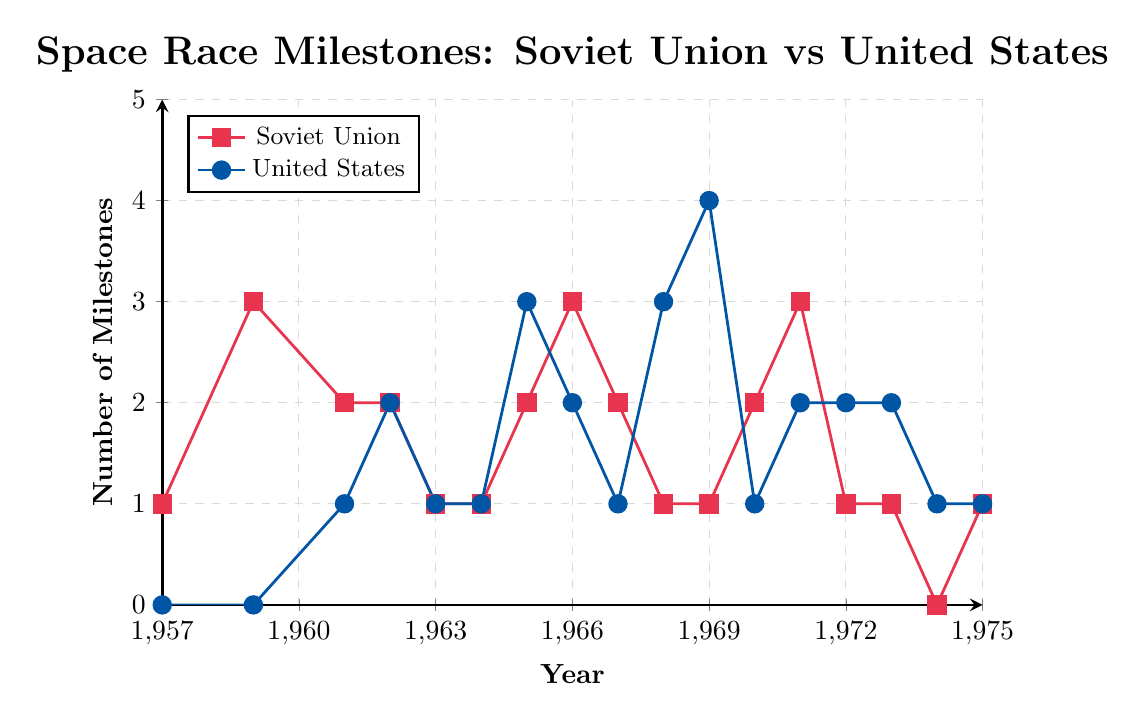What year did the Soviet Union achieve the highest number of space race milestones? To determine the year when the Soviet Union achieved the highest number of space race milestones, observe the red line in the figure and find the peak. The peak appears to be in 1959, 1966, and 1971, where the milestones reached 3.
Answer: 1959, 1966, and 1971 In which year did the United States achieve its highest number of space race milestones, and what was that number? Look at the blue line in the figure and identify its highest point. The highest number is 4, which occurs in 1969.
Answer: 1969, 4 How many more milestones did the Soviet Union achieve in 1959 compared to the United States in the same year? Observe the difference in the height of the lines at the year 1959: The Soviet Union achieved 3 milestones, and the United States achieved 0. The difference is 3 - 0 = 3.
Answer: 3 What is the sum of space race milestones for the Soviet Union from 1970 to 1975? Add the milestones for the years from 1970 to 1975 for the Soviet Union: 2 (1970) + 3 (1971) + 1 (1972) + 1 (1973) + 0 (1974) + 1 (1975). The sum is 2 + 3 + 1 + 1 + 0 + 1 = 8.
Answer: 8 In which year did both the Soviet Union and the United States have an equal number of milestones, and what was that number? Identify the years where the red and blue lines overlap. Such years are: 1962 (both 2), 1963 (both 1), 1964 (both 1), and 1975 (both 1).
Answer: 1962, 1963, 1964, 1975; 1 or 2 (depending on the year) Between 1957 and 1967, did the Soviet Union achieve more milestones than the United States? Sum the milestones for both countries in the given range: Soviet Union: 1 + 3 + 2 + 2 + 1 + 1 + 2 + 3 + 2 + 1 = 18; United States: 0 + 0 + 1 + 2 + 1 + 1 + 3 + 2 + 1 + 1 = 12. The Soviet Union (18) achieved more milestones than the United States (12).
Answer: Yes How did the milestone achievements of the United States change from 1968 to 1969? Compare the milestones: In 1968, the United States had 3 milestones. In 1969, it increased to 4. This shows an increase by 1 milestone from 1968 to 1969.
Answer: Increased by 1 Which country had more years with zero milestones, and how many such years did they have? Count the years with zero milestones for both countries: Soviet Union had 0 milestones in 1974 (1 year). The United States had 0 milestones in 1957 and 1959 (2 years). The United States had more years with zero milestones.
Answer: United States, 2 What are the milestone counts for both countries in the year 1965? Identify the milestone counts for the year 1965: The Soviet Union had 2 milestones, and the United States had 3 milestones.
Answer: Soviet Union: 2, United States: 3 